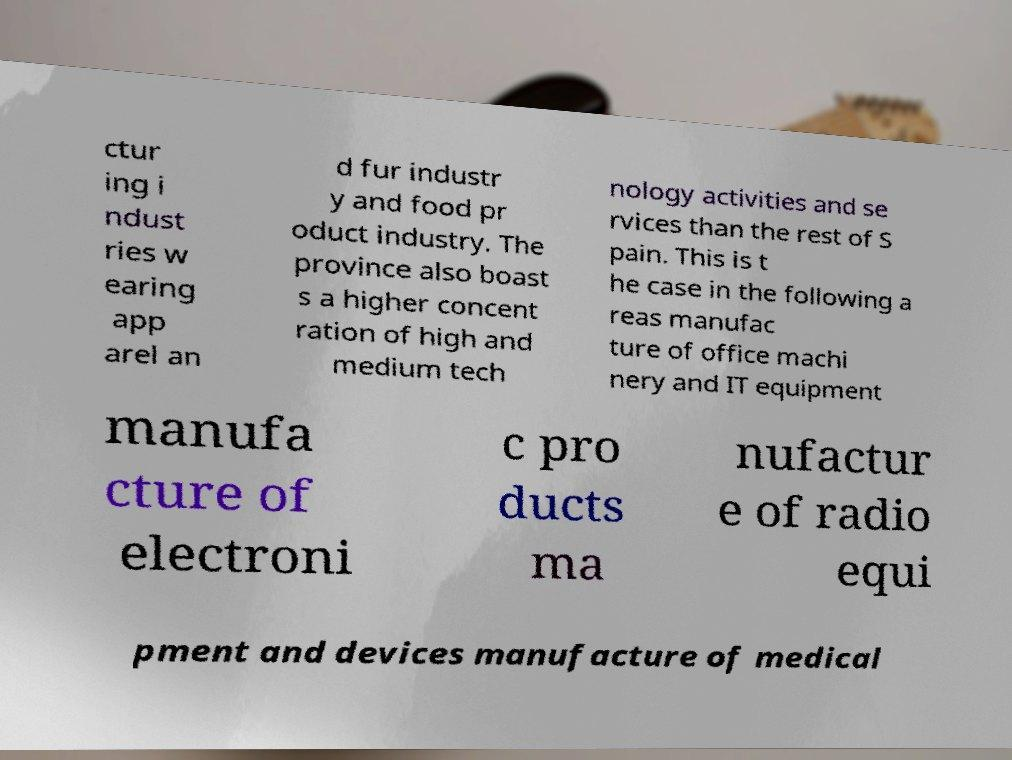Please identify and transcribe the text found in this image. ctur ing i ndust ries w earing app arel an d fur industr y and food pr oduct industry. The province also boast s a higher concent ration of high and medium tech nology activities and se rvices than the rest of S pain. This is t he case in the following a reas manufac ture of office machi nery and IT equipment manufa cture of electroni c pro ducts ma nufactur e of radio equi pment and devices manufacture of medical 